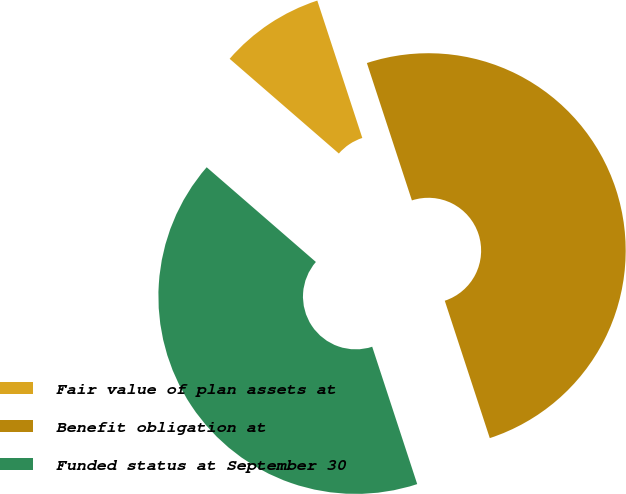Convert chart. <chart><loc_0><loc_0><loc_500><loc_500><pie_chart><fcel>Fair value of plan assets at<fcel>Benefit obligation at<fcel>Funded status at September 30<nl><fcel>8.59%<fcel>50.0%<fcel>41.41%<nl></chart> 